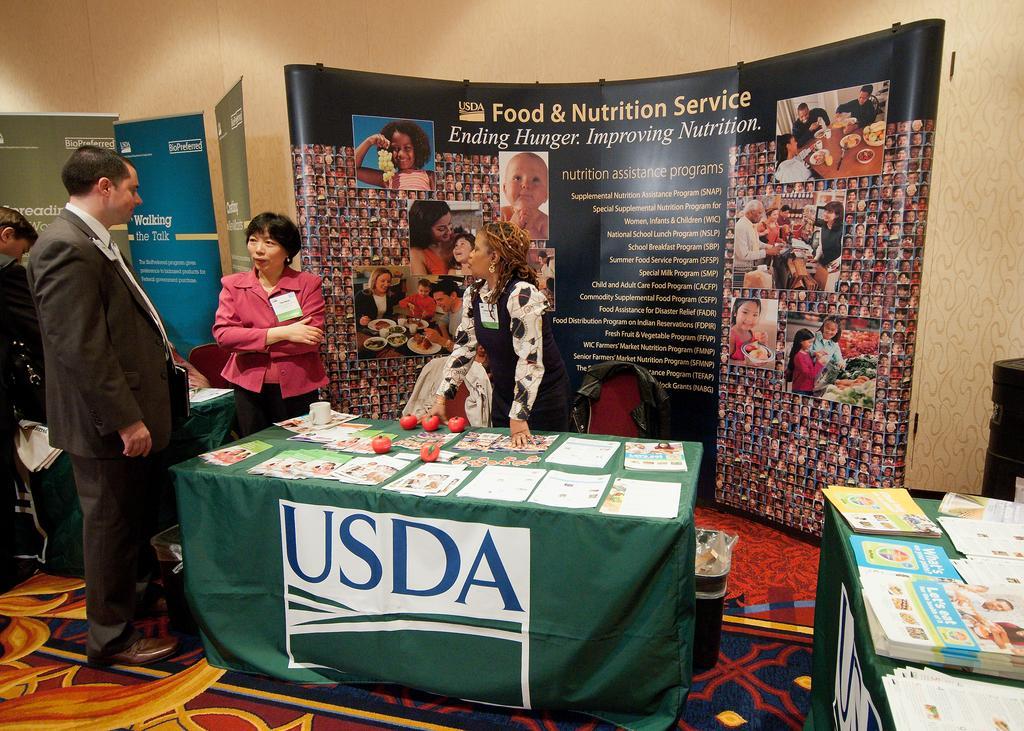Please provide a concise description of this image. In this image there are people standing in front of the tables. On top of the tables there are peppers, fruits, books and a cup. In the background of the image there are banners. There is a wall. On the right side of the image there is some object. There is a dustbin. 